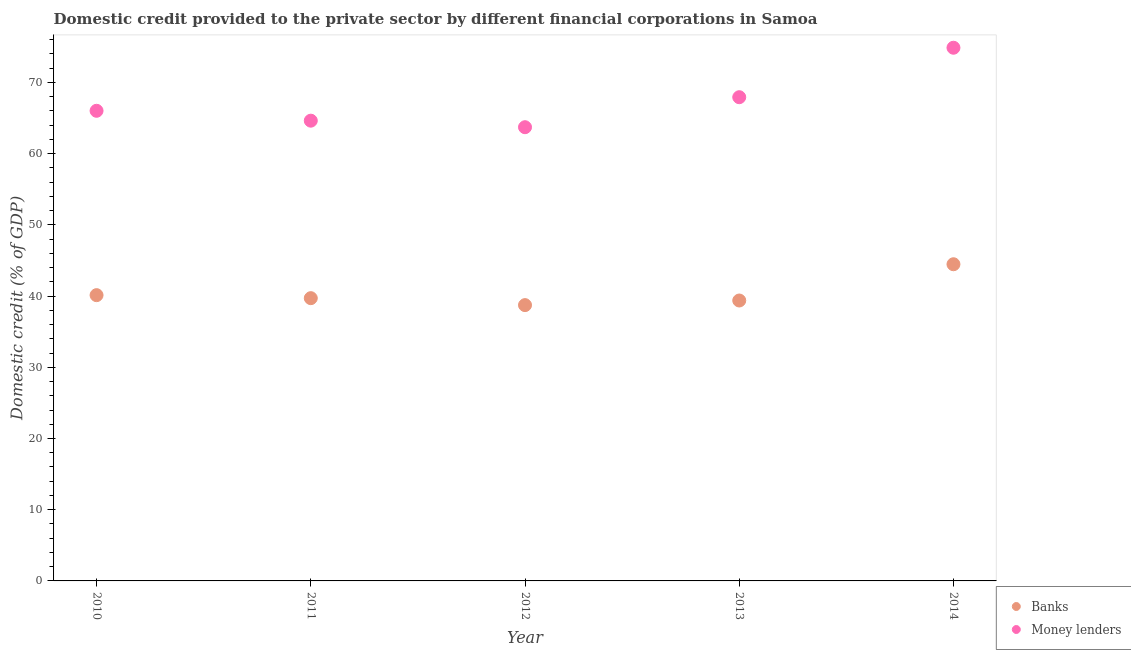Is the number of dotlines equal to the number of legend labels?
Your response must be concise. Yes. What is the domestic credit provided by money lenders in 2013?
Ensure brevity in your answer.  67.92. Across all years, what is the maximum domestic credit provided by banks?
Your answer should be compact. 44.47. Across all years, what is the minimum domestic credit provided by money lenders?
Give a very brief answer. 63.71. What is the total domestic credit provided by banks in the graph?
Provide a short and direct response. 202.4. What is the difference between the domestic credit provided by banks in 2012 and that in 2014?
Provide a short and direct response. -5.74. What is the difference between the domestic credit provided by money lenders in 2010 and the domestic credit provided by banks in 2012?
Ensure brevity in your answer.  27.29. What is the average domestic credit provided by money lenders per year?
Offer a very short reply. 67.43. In the year 2013, what is the difference between the domestic credit provided by banks and domestic credit provided by money lenders?
Your answer should be compact. -28.55. In how many years, is the domestic credit provided by money lenders greater than 44 %?
Your answer should be very brief. 5. What is the ratio of the domestic credit provided by money lenders in 2012 to that in 2013?
Give a very brief answer. 0.94. Is the difference between the domestic credit provided by banks in 2010 and 2013 greater than the difference between the domestic credit provided by money lenders in 2010 and 2013?
Make the answer very short. Yes. What is the difference between the highest and the second highest domestic credit provided by banks?
Your answer should be compact. 4.34. What is the difference between the highest and the lowest domestic credit provided by banks?
Your answer should be compact. 5.74. In how many years, is the domestic credit provided by banks greater than the average domestic credit provided by banks taken over all years?
Give a very brief answer. 1. Is the sum of the domestic credit provided by banks in 2012 and 2013 greater than the maximum domestic credit provided by money lenders across all years?
Give a very brief answer. Yes. Does the domestic credit provided by money lenders monotonically increase over the years?
Make the answer very short. No. Is the domestic credit provided by money lenders strictly greater than the domestic credit provided by banks over the years?
Your answer should be compact. Yes. How many dotlines are there?
Make the answer very short. 2. How many years are there in the graph?
Make the answer very short. 5. What is the difference between two consecutive major ticks on the Y-axis?
Ensure brevity in your answer.  10. Are the values on the major ticks of Y-axis written in scientific E-notation?
Offer a very short reply. No. Does the graph contain any zero values?
Make the answer very short. No. Where does the legend appear in the graph?
Provide a succinct answer. Bottom right. How many legend labels are there?
Your response must be concise. 2. How are the legend labels stacked?
Your response must be concise. Vertical. What is the title of the graph?
Offer a very short reply. Domestic credit provided to the private sector by different financial corporations in Samoa. Does "Not attending school" appear as one of the legend labels in the graph?
Offer a very short reply. No. What is the label or title of the Y-axis?
Provide a short and direct response. Domestic credit (% of GDP). What is the Domestic credit (% of GDP) of Banks in 2010?
Make the answer very short. 40.13. What is the Domestic credit (% of GDP) of Money lenders in 2010?
Keep it short and to the point. 66.01. What is the Domestic credit (% of GDP) in Banks in 2011?
Offer a very short reply. 39.7. What is the Domestic credit (% of GDP) in Money lenders in 2011?
Offer a terse response. 64.63. What is the Domestic credit (% of GDP) of Banks in 2012?
Provide a short and direct response. 38.73. What is the Domestic credit (% of GDP) in Money lenders in 2012?
Your response must be concise. 63.71. What is the Domestic credit (% of GDP) of Banks in 2013?
Ensure brevity in your answer.  39.38. What is the Domestic credit (% of GDP) of Money lenders in 2013?
Offer a terse response. 67.92. What is the Domestic credit (% of GDP) in Banks in 2014?
Offer a terse response. 44.47. What is the Domestic credit (% of GDP) in Money lenders in 2014?
Keep it short and to the point. 74.87. Across all years, what is the maximum Domestic credit (% of GDP) in Banks?
Offer a terse response. 44.47. Across all years, what is the maximum Domestic credit (% of GDP) of Money lenders?
Make the answer very short. 74.87. Across all years, what is the minimum Domestic credit (% of GDP) of Banks?
Provide a succinct answer. 38.73. Across all years, what is the minimum Domestic credit (% of GDP) of Money lenders?
Your answer should be very brief. 63.71. What is the total Domestic credit (% of GDP) of Banks in the graph?
Offer a very short reply. 202.4. What is the total Domestic credit (% of GDP) in Money lenders in the graph?
Make the answer very short. 337.14. What is the difference between the Domestic credit (% of GDP) in Banks in 2010 and that in 2011?
Your answer should be very brief. 0.42. What is the difference between the Domestic credit (% of GDP) in Money lenders in 2010 and that in 2011?
Your answer should be compact. 1.39. What is the difference between the Domestic credit (% of GDP) of Banks in 2010 and that in 2012?
Ensure brevity in your answer.  1.4. What is the difference between the Domestic credit (% of GDP) of Money lenders in 2010 and that in 2012?
Give a very brief answer. 2.31. What is the difference between the Domestic credit (% of GDP) in Banks in 2010 and that in 2013?
Provide a succinct answer. 0.75. What is the difference between the Domestic credit (% of GDP) in Money lenders in 2010 and that in 2013?
Offer a very short reply. -1.91. What is the difference between the Domestic credit (% of GDP) in Banks in 2010 and that in 2014?
Keep it short and to the point. -4.34. What is the difference between the Domestic credit (% of GDP) in Money lenders in 2010 and that in 2014?
Keep it short and to the point. -8.85. What is the difference between the Domestic credit (% of GDP) in Banks in 2011 and that in 2012?
Your answer should be very brief. 0.98. What is the difference between the Domestic credit (% of GDP) of Money lenders in 2011 and that in 2012?
Make the answer very short. 0.92. What is the difference between the Domestic credit (% of GDP) in Banks in 2011 and that in 2013?
Provide a short and direct response. 0.33. What is the difference between the Domestic credit (% of GDP) of Money lenders in 2011 and that in 2013?
Your response must be concise. -3.3. What is the difference between the Domestic credit (% of GDP) in Banks in 2011 and that in 2014?
Your response must be concise. -4.76. What is the difference between the Domestic credit (% of GDP) of Money lenders in 2011 and that in 2014?
Ensure brevity in your answer.  -10.24. What is the difference between the Domestic credit (% of GDP) of Banks in 2012 and that in 2013?
Give a very brief answer. -0.65. What is the difference between the Domestic credit (% of GDP) of Money lenders in 2012 and that in 2013?
Your response must be concise. -4.21. What is the difference between the Domestic credit (% of GDP) of Banks in 2012 and that in 2014?
Keep it short and to the point. -5.74. What is the difference between the Domestic credit (% of GDP) in Money lenders in 2012 and that in 2014?
Give a very brief answer. -11.16. What is the difference between the Domestic credit (% of GDP) in Banks in 2013 and that in 2014?
Provide a succinct answer. -5.09. What is the difference between the Domestic credit (% of GDP) in Money lenders in 2013 and that in 2014?
Offer a terse response. -6.95. What is the difference between the Domestic credit (% of GDP) of Banks in 2010 and the Domestic credit (% of GDP) of Money lenders in 2011?
Offer a very short reply. -24.5. What is the difference between the Domestic credit (% of GDP) of Banks in 2010 and the Domestic credit (% of GDP) of Money lenders in 2012?
Make the answer very short. -23.58. What is the difference between the Domestic credit (% of GDP) of Banks in 2010 and the Domestic credit (% of GDP) of Money lenders in 2013?
Your response must be concise. -27.8. What is the difference between the Domestic credit (% of GDP) of Banks in 2010 and the Domestic credit (% of GDP) of Money lenders in 2014?
Keep it short and to the point. -34.74. What is the difference between the Domestic credit (% of GDP) of Banks in 2011 and the Domestic credit (% of GDP) of Money lenders in 2012?
Provide a short and direct response. -24.01. What is the difference between the Domestic credit (% of GDP) in Banks in 2011 and the Domestic credit (% of GDP) in Money lenders in 2013?
Your response must be concise. -28.22. What is the difference between the Domestic credit (% of GDP) of Banks in 2011 and the Domestic credit (% of GDP) of Money lenders in 2014?
Ensure brevity in your answer.  -35.16. What is the difference between the Domestic credit (% of GDP) in Banks in 2012 and the Domestic credit (% of GDP) in Money lenders in 2013?
Your response must be concise. -29.19. What is the difference between the Domestic credit (% of GDP) in Banks in 2012 and the Domestic credit (% of GDP) in Money lenders in 2014?
Ensure brevity in your answer.  -36.14. What is the difference between the Domestic credit (% of GDP) of Banks in 2013 and the Domestic credit (% of GDP) of Money lenders in 2014?
Ensure brevity in your answer.  -35.49. What is the average Domestic credit (% of GDP) of Banks per year?
Offer a very short reply. 40.48. What is the average Domestic credit (% of GDP) of Money lenders per year?
Offer a very short reply. 67.43. In the year 2010, what is the difference between the Domestic credit (% of GDP) of Banks and Domestic credit (% of GDP) of Money lenders?
Your response must be concise. -25.89. In the year 2011, what is the difference between the Domestic credit (% of GDP) in Banks and Domestic credit (% of GDP) in Money lenders?
Your answer should be very brief. -24.92. In the year 2012, what is the difference between the Domestic credit (% of GDP) of Banks and Domestic credit (% of GDP) of Money lenders?
Make the answer very short. -24.98. In the year 2013, what is the difference between the Domestic credit (% of GDP) in Banks and Domestic credit (% of GDP) in Money lenders?
Give a very brief answer. -28.55. In the year 2014, what is the difference between the Domestic credit (% of GDP) of Banks and Domestic credit (% of GDP) of Money lenders?
Offer a very short reply. -30.4. What is the ratio of the Domestic credit (% of GDP) in Banks in 2010 to that in 2011?
Make the answer very short. 1.01. What is the ratio of the Domestic credit (% of GDP) in Money lenders in 2010 to that in 2011?
Offer a very short reply. 1.02. What is the ratio of the Domestic credit (% of GDP) in Banks in 2010 to that in 2012?
Make the answer very short. 1.04. What is the ratio of the Domestic credit (% of GDP) in Money lenders in 2010 to that in 2012?
Give a very brief answer. 1.04. What is the ratio of the Domestic credit (% of GDP) of Banks in 2010 to that in 2013?
Provide a short and direct response. 1.02. What is the ratio of the Domestic credit (% of GDP) in Money lenders in 2010 to that in 2013?
Provide a short and direct response. 0.97. What is the ratio of the Domestic credit (% of GDP) of Banks in 2010 to that in 2014?
Provide a succinct answer. 0.9. What is the ratio of the Domestic credit (% of GDP) in Money lenders in 2010 to that in 2014?
Provide a short and direct response. 0.88. What is the ratio of the Domestic credit (% of GDP) of Banks in 2011 to that in 2012?
Provide a short and direct response. 1.03. What is the ratio of the Domestic credit (% of GDP) of Money lenders in 2011 to that in 2012?
Provide a short and direct response. 1.01. What is the ratio of the Domestic credit (% of GDP) of Banks in 2011 to that in 2013?
Your response must be concise. 1.01. What is the ratio of the Domestic credit (% of GDP) of Money lenders in 2011 to that in 2013?
Your response must be concise. 0.95. What is the ratio of the Domestic credit (% of GDP) of Banks in 2011 to that in 2014?
Ensure brevity in your answer.  0.89. What is the ratio of the Domestic credit (% of GDP) in Money lenders in 2011 to that in 2014?
Give a very brief answer. 0.86. What is the ratio of the Domestic credit (% of GDP) of Banks in 2012 to that in 2013?
Your answer should be compact. 0.98. What is the ratio of the Domestic credit (% of GDP) of Money lenders in 2012 to that in 2013?
Your response must be concise. 0.94. What is the ratio of the Domestic credit (% of GDP) of Banks in 2012 to that in 2014?
Your response must be concise. 0.87. What is the ratio of the Domestic credit (% of GDP) of Money lenders in 2012 to that in 2014?
Your answer should be very brief. 0.85. What is the ratio of the Domestic credit (% of GDP) of Banks in 2013 to that in 2014?
Provide a succinct answer. 0.89. What is the ratio of the Domestic credit (% of GDP) in Money lenders in 2013 to that in 2014?
Your answer should be very brief. 0.91. What is the difference between the highest and the second highest Domestic credit (% of GDP) of Banks?
Your answer should be very brief. 4.34. What is the difference between the highest and the second highest Domestic credit (% of GDP) of Money lenders?
Offer a very short reply. 6.95. What is the difference between the highest and the lowest Domestic credit (% of GDP) of Banks?
Provide a short and direct response. 5.74. What is the difference between the highest and the lowest Domestic credit (% of GDP) of Money lenders?
Your answer should be very brief. 11.16. 